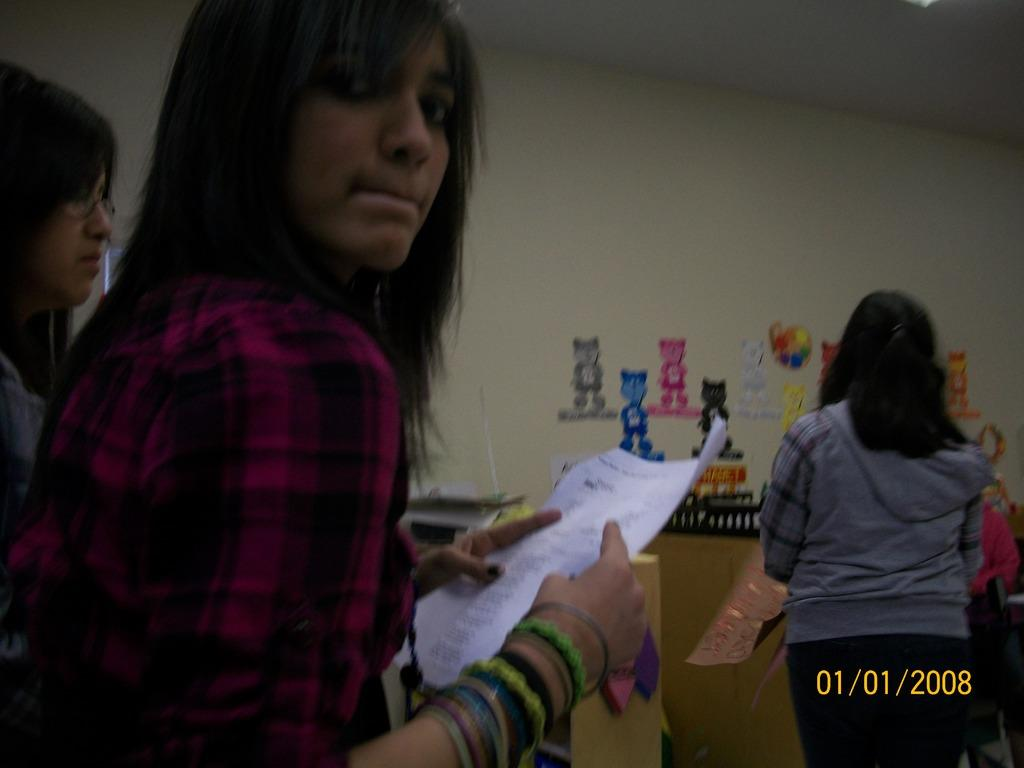<image>
Describe the image concisely. Some women are in a classroom holding some papers with the date 01/01/2008. 